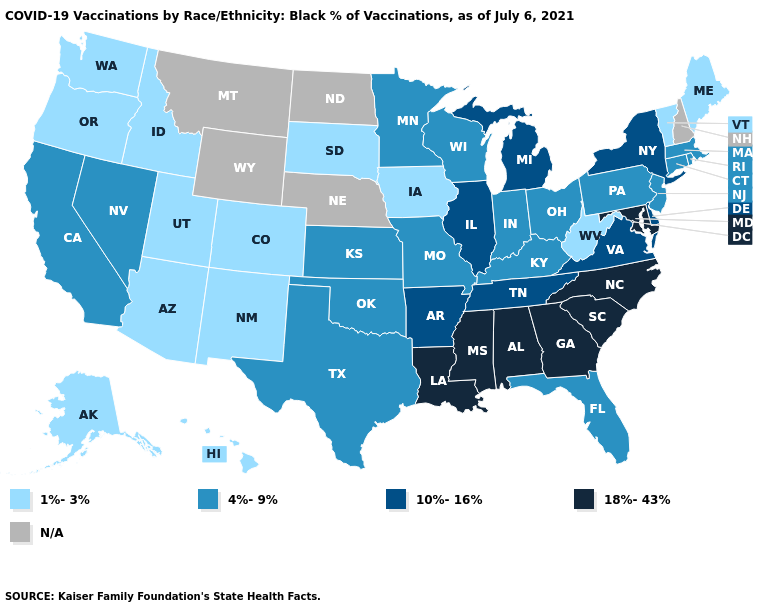What is the highest value in the USA?
Write a very short answer. 18%-43%. What is the highest value in states that border Wisconsin?
Concise answer only. 10%-16%. What is the highest value in the USA?
Answer briefly. 18%-43%. Does Nevada have the lowest value in the West?
Short answer required. No. What is the lowest value in the USA?
Keep it brief. 1%-3%. Name the states that have a value in the range 1%-3%?
Concise answer only. Alaska, Arizona, Colorado, Hawaii, Idaho, Iowa, Maine, New Mexico, Oregon, South Dakota, Utah, Vermont, Washington, West Virginia. Name the states that have a value in the range 4%-9%?
Answer briefly. California, Connecticut, Florida, Indiana, Kansas, Kentucky, Massachusetts, Minnesota, Missouri, Nevada, New Jersey, Ohio, Oklahoma, Pennsylvania, Rhode Island, Texas, Wisconsin. Among the states that border New Jersey , does Pennsylvania have the lowest value?
Short answer required. Yes. What is the highest value in the USA?
Write a very short answer. 18%-43%. Name the states that have a value in the range N/A?
Write a very short answer. Montana, Nebraska, New Hampshire, North Dakota, Wyoming. What is the value of New York?
Concise answer only. 10%-16%. Name the states that have a value in the range 1%-3%?
Keep it brief. Alaska, Arizona, Colorado, Hawaii, Idaho, Iowa, Maine, New Mexico, Oregon, South Dakota, Utah, Vermont, Washington, West Virginia. What is the value of Wisconsin?
Answer briefly. 4%-9%. Does the map have missing data?
Answer briefly. Yes. 